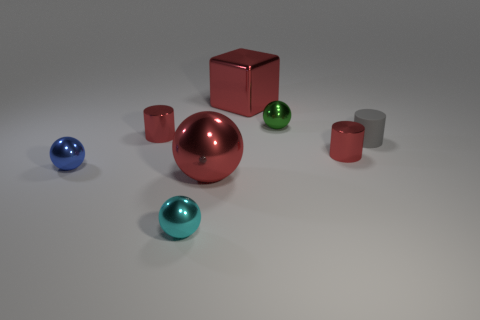Is the number of cubes that are on the right side of the tiny matte thing greater than the number of red cylinders?
Ensure brevity in your answer.  No. What is the shape of the blue metal thing that is behind the small cyan ball?
Provide a succinct answer. Sphere. How many other things are there of the same shape as the tiny gray matte thing?
Your response must be concise. 2. Is the cylinder that is on the left side of the big shiny ball made of the same material as the big red sphere?
Your response must be concise. Yes. Is the number of tiny gray rubber objects that are in front of the tiny rubber cylinder the same as the number of metallic spheres that are to the right of the small blue metallic thing?
Offer a very short reply. No. What size is the red shiny cylinder behind the small gray matte cylinder?
Your answer should be compact. Small. Are there any blue spheres made of the same material as the small gray object?
Give a very brief answer. No. There is a object behind the green metallic thing; is it the same color as the matte cylinder?
Make the answer very short. No. Are there an equal number of tiny red cylinders on the left side of the small green shiny thing and red things?
Keep it short and to the point. No. Is there a metal cylinder of the same color as the big sphere?
Provide a short and direct response. Yes. 